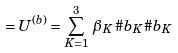Convert formula to latex. <formula><loc_0><loc_0><loc_500><loc_500>\ = U ^ { ( b ) } = \sum _ { K = 1 } ^ { 3 } \, \beta _ { K } \, \# b _ { K } \# b _ { K }</formula> 